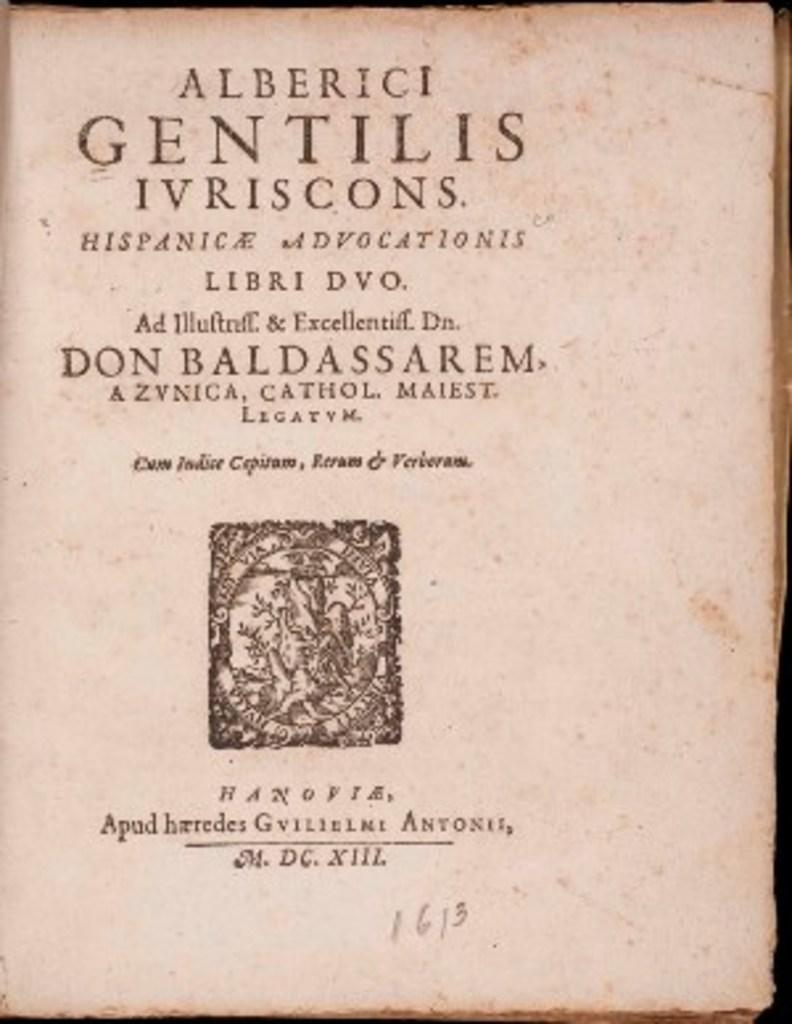What type of image is this? The image is a cover. What can be found on the cover? There is text on the cover. Where is the logo located on the cover? The logo is in the center of the cover. What type of suit is the person wearing on the cover? There is no person visible on the cover, and therefore no suit can be observed. How many cubes are present on the cover? There are no cubes present on the cover; it features text and a logo. 